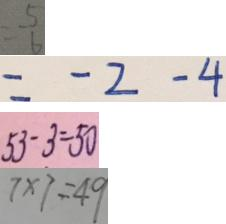Convert formula to latex. <formula><loc_0><loc_0><loc_500><loc_500>= \frac { 5 } { 6 } 
 = - 2 - 4 
 5 3 - 3 = 5 0 
 7 \times 7 = 4 9</formula> 